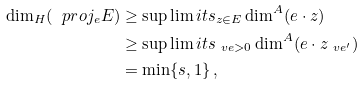Convert formula to latex. <formula><loc_0><loc_0><loc_500><loc_500>\dim _ { H } ( \ p r o j _ { e } E ) & \geq \sup \lim i t s _ { z \in E } \dim ^ { A } ( e \cdot z ) \\ & \geq \sup \lim i t s _ { \ v e > 0 } \dim ^ { A } ( e \cdot z _ { \ v e ^ { \prime } } ) \\ & = \min \{ s , 1 \} \, ,</formula> 